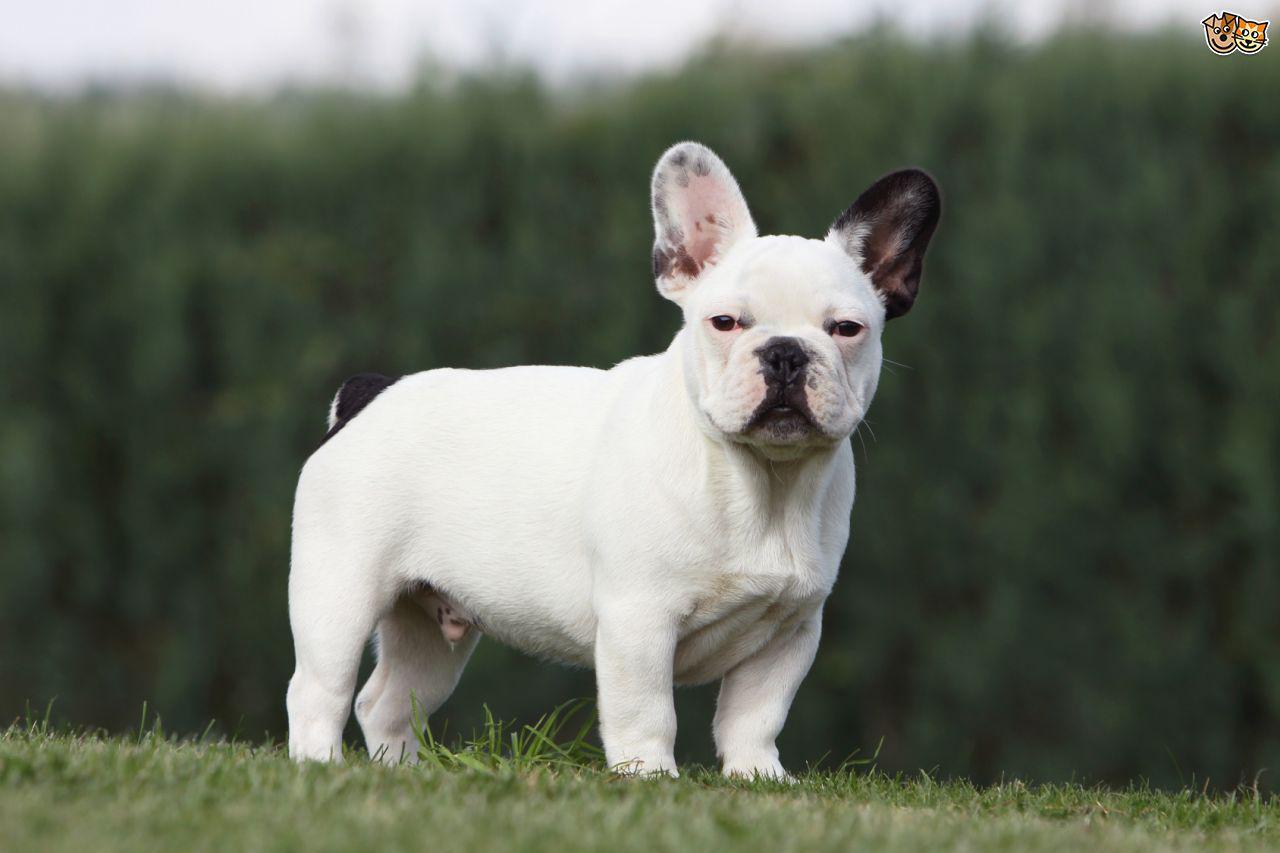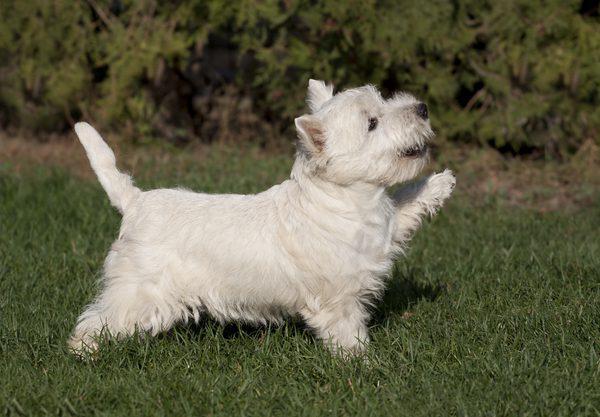The first image is the image on the left, the second image is the image on the right. Evaluate the accuracy of this statement regarding the images: "An image shows a gray dog with a white mark on its chest.". Is it true? Answer yes or no. No. 